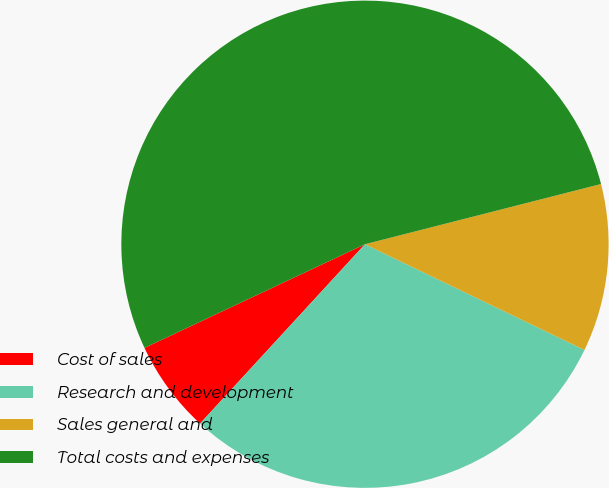<chart> <loc_0><loc_0><loc_500><loc_500><pie_chart><fcel>Cost of sales<fcel>Research and development<fcel>Sales general and<fcel>Total costs and expenses<nl><fcel>6.17%<fcel>29.69%<fcel>11.12%<fcel>53.02%<nl></chart> 